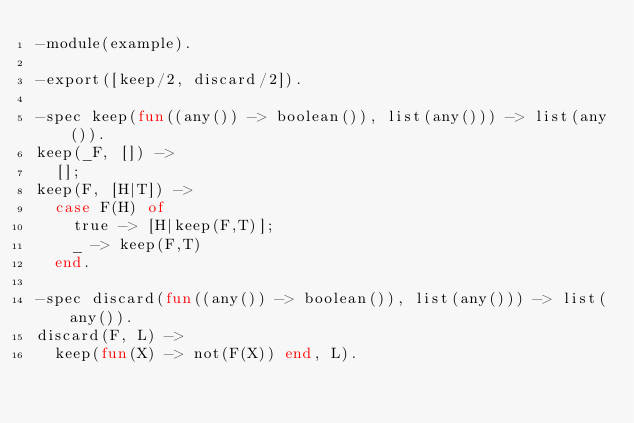Convert code to text. <code><loc_0><loc_0><loc_500><loc_500><_Erlang_>-module(example).

-export([keep/2, discard/2]).

-spec keep(fun((any()) -> boolean()), list(any())) -> list(any()).
keep(_F, []) ->
  [];
keep(F, [H|T]) ->
  case F(H) of
    true -> [H|keep(F,T)];
    _ -> keep(F,T)
  end.

-spec discard(fun((any()) -> boolean()), list(any())) -> list(any()).
discard(F, L) ->
  keep(fun(X) -> not(F(X)) end, L).
</code> 